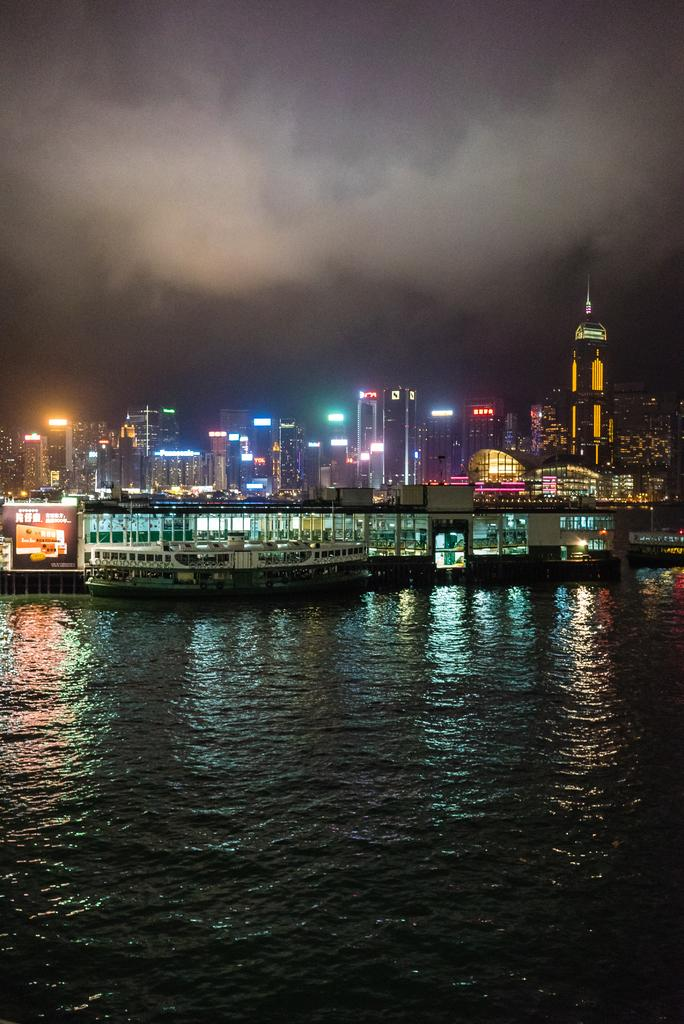What is visible in the image? Water is visible in the image. What can be seen in the background of the image? There are boats and buildings in the background of the image. What else is present in the image? There are lights visible in the image. How is the sky depicted in the image? The sky is depicted in white, gray, and black colors. What type of eggnog is being served by the sister in the image? There is no sister or eggnog present in the image. What scientific theory is being discussed in the image? There is no discussion of a scientific theory in the image. 